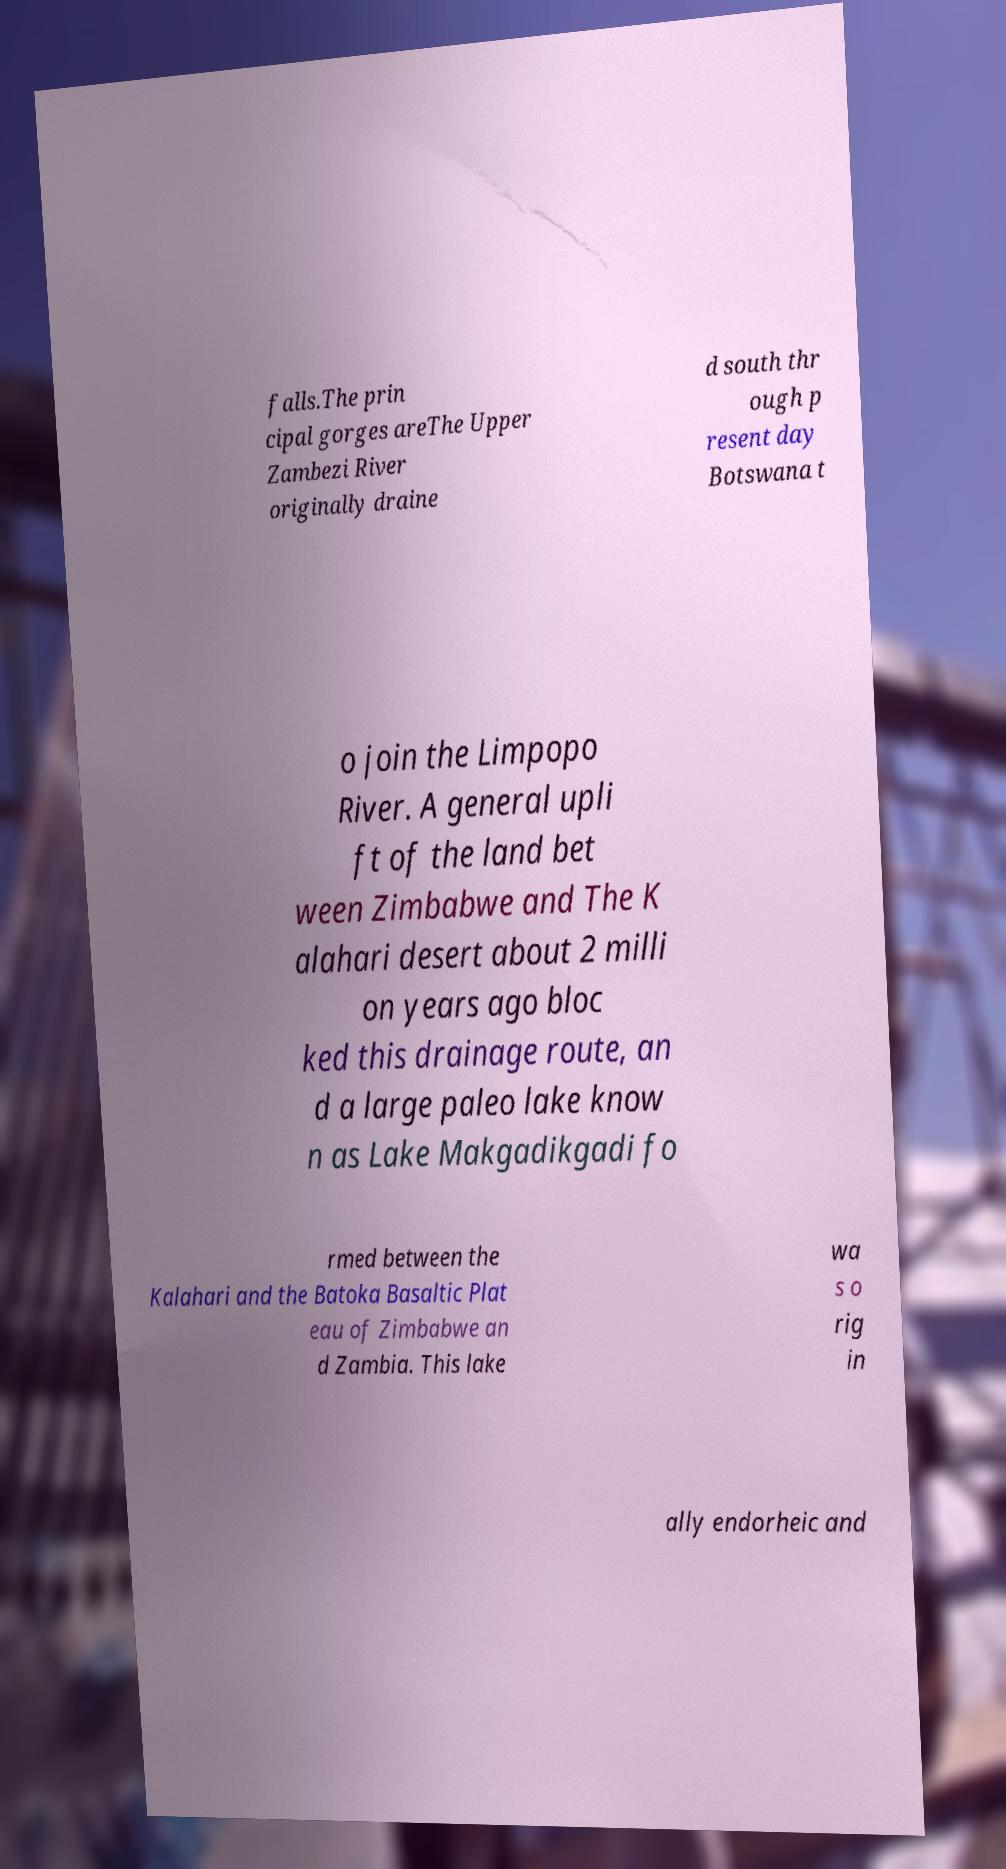Please identify and transcribe the text found in this image. falls.The prin cipal gorges areThe Upper Zambezi River originally draine d south thr ough p resent day Botswana t o join the Limpopo River. A general upli ft of the land bet ween Zimbabwe and The K alahari desert about 2 milli on years ago bloc ked this drainage route, an d a large paleo lake know n as Lake Makgadikgadi fo rmed between the Kalahari and the Batoka Basaltic Plat eau of Zimbabwe an d Zambia. This lake wa s o rig in ally endorheic and 